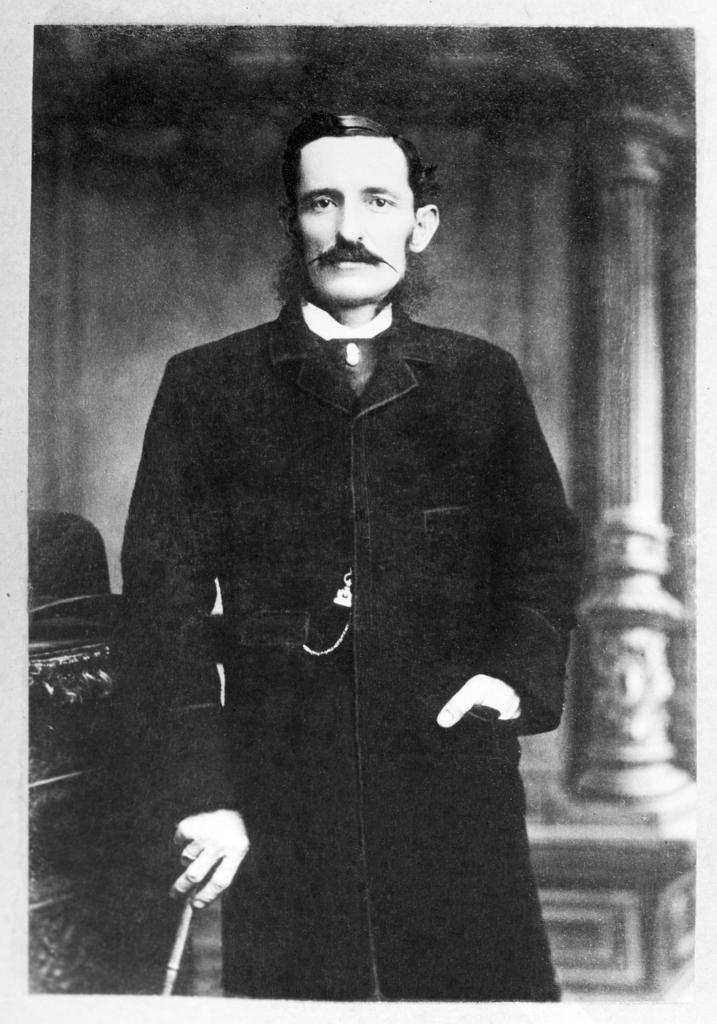Who is present in the image? There is a man in the image. What is the man doing in the image? The man is standing beside an object and posing for a photo. What can be seen behind the man in the image? There is a pillar behind the man in the image. What type of cracker is the man holding in the image? There is no cracker present in the image; the man is posing for a photo while standing beside an object. 